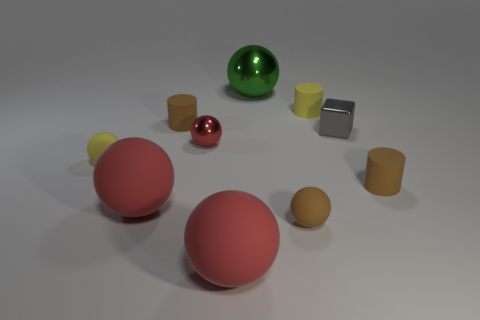How many red spheres must be subtracted to get 1 red spheres? 2 Subtract all brown cylinders. How many cylinders are left? 1 Subtract all yellow cylinders. How many cylinders are left? 2 Subtract 1 blocks. How many blocks are left? 0 Subtract all blocks. How many objects are left? 9 Subtract all small matte balls. Subtract all large red balls. How many objects are left? 6 Add 6 tiny metallic objects. How many tiny metallic objects are left? 8 Add 8 red rubber things. How many red rubber things exist? 10 Subtract 0 gray balls. How many objects are left? 10 Subtract all yellow blocks. Subtract all gray balls. How many blocks are left? 1 